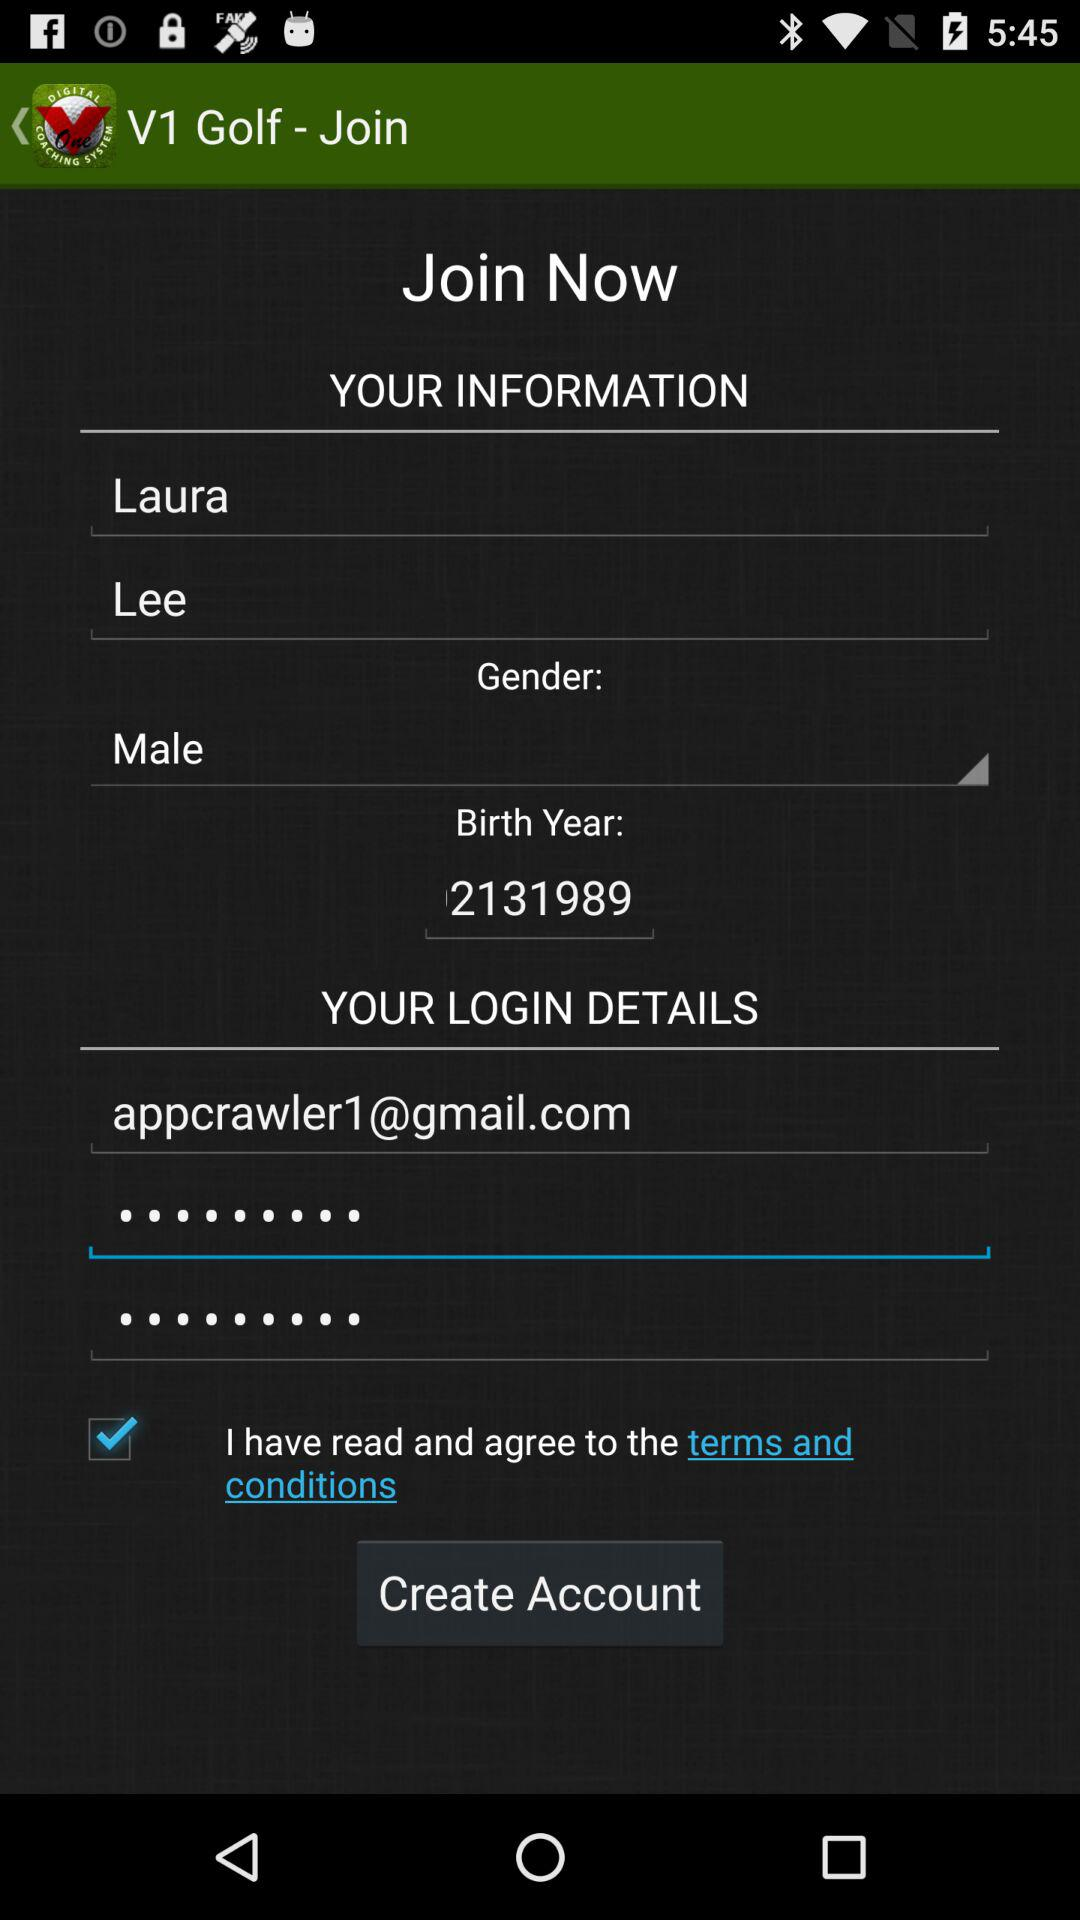What is the gender of the person? The gender of the person is male. 